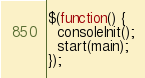<code> <loc_0><loc_0><loc_500><loc_500><_JavaScript_>
$(function() {
  consoleInit();
  start(main);
});
</code> 